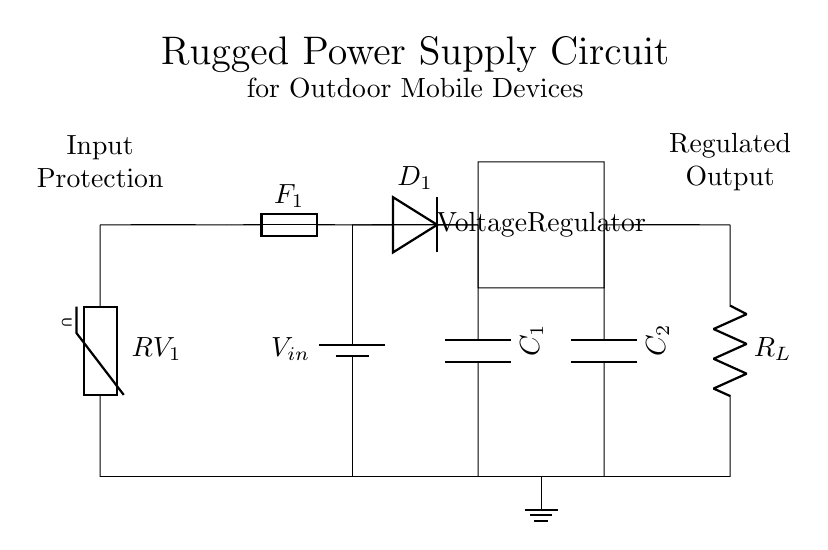What is the main purpose of the voltage regulator in this circuit? The voltage regulator is essential for providing a stable output voltage despite variations in the input voltage and load conditions. It ensures that the connected components function correctly without damage due to voltage fluctuations.
Answer: Stable output voltage What does the capacitor C1 do in this circuit? Capacitor C1 functions as a filter to smooth out the voltage, reducing ripple, and maintaining stability in the supply voltage at the input of the voltage regulator.
Answer: Smoothing voltage Which component provides protection against reverse polarity? The diode D1 is positioned to prevent damage from reverse polarity by allowing current to flow only in one direction. If the voltage is applied in the wrong direction, the diode blocks the current.
Answer: Diode How does the fuse F1 protect the circuit? The fuse F1 interrupts the current flow in case of an overcurrent scenario, preventing potential damage to the connected components by melting its link when the current exceeds its rated capacity.
Answer: Prevents overcurrent What is the role of the varistor RV1 in this circuit? The varistor RV1 protects the circuit from voltage spikes by shunting excess voltage away, effectively limiting the voltage that reaches sensitive components, thereby preventing damage.
Answer: Voltage spike protection What is the output component labeled R_L in the circuit? R_L represents the load resistor, which simulates the presence of a device using the power supply, allowing the circuit to test the power delivery and behavior under load conditions.
Answer: Load resistor What is the significance of having both C1 and C2 in the circuit? Both capacitors C1 and C2 serve different filtering roles: C1 primarily smooths the input voltage, while C2 stabilizes the output voltage, improving the circuit’s performance under varying load or input conditions.
Answer: Filtering at input and output 